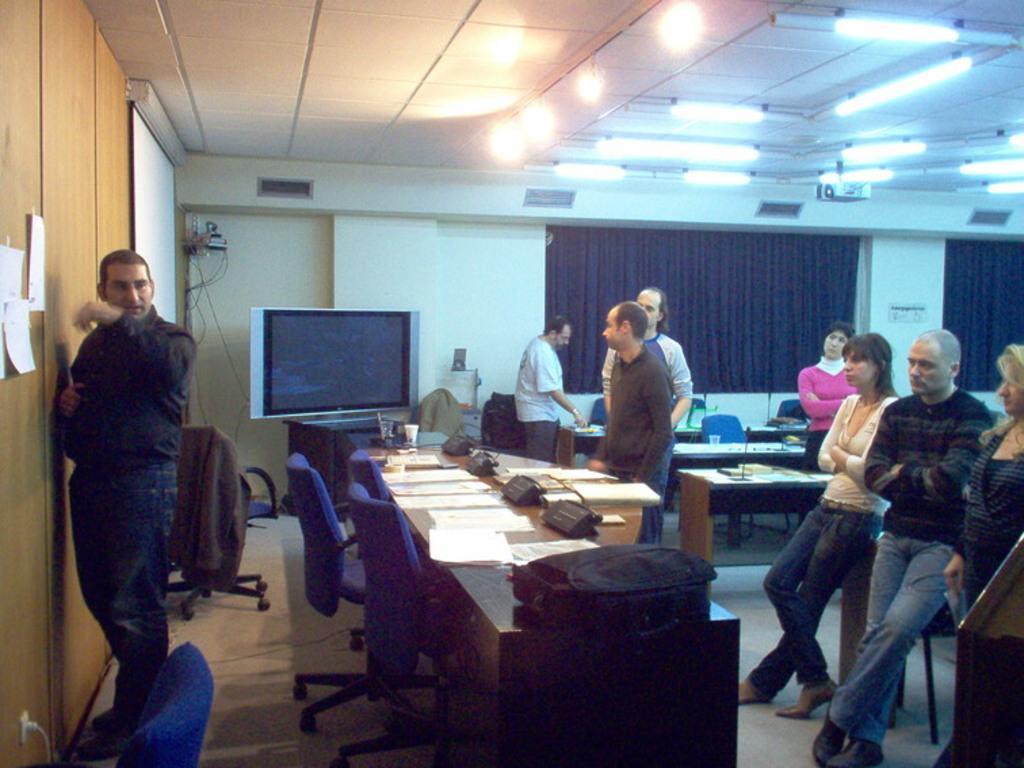In one or two sentences, can you explain what this image depicts? In this room we have some chairs and desk on which we have some papers and some and we have a screen and a projector. There are a group of people who are leaning on the desk and a guy who is facing to the wall side. 